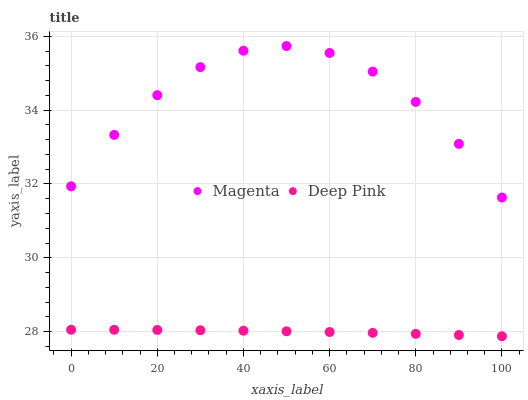Does Deep Pink have the minimum area under the curve?
Answer yes or no. Yes. Does Magenta have the maximum area under the curve?
Answer yes or no. Yes. Does Deep Pink have the maximum area under the curve?
Answer yes or no. No. Is Deep Pink the smoothest?
Answer yes or no. Yes. Is Magenta the roughest?
Answer yes or no. Yes. Is Deep Pink the roughest?
Answer yes or no. No. Does Deep Pink have the lowest value?
Answer yes or no. Yes. Does Magenta have the highest value?
Answer yes or no. Yes. Does Deep Pink have the highest value?
Answer yes or no. No. Is Deep Pink less than Magenta?
Answer yes or no. Yes. Is Magenta greater than Deep Pink?
Answer yes or no. Yes. Does Deep Pink intersect Magenta?
Answer yes or no. No. 